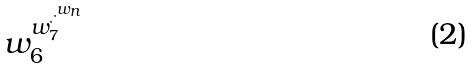<formula> <loc_0><loc_0><loc_500><loc_500>w _ { 6 } ^ { w _ { 7 } ^ { \cdot ^ { \cdot ^ { w _ { n } } } } }</formula> 